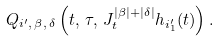Convert formula to latex. <formula><loc_0><loc_0><loc_500><loc_500>Q _ { i ^ { \prime } , \, \beta , \, \delta } \left ( t , \, \tau , \, J _ { t } ^ { | \beta | + | \delta | } h _ { i _ { 1 } ^ { \prime } } ( t ) \right ) .</formula> 